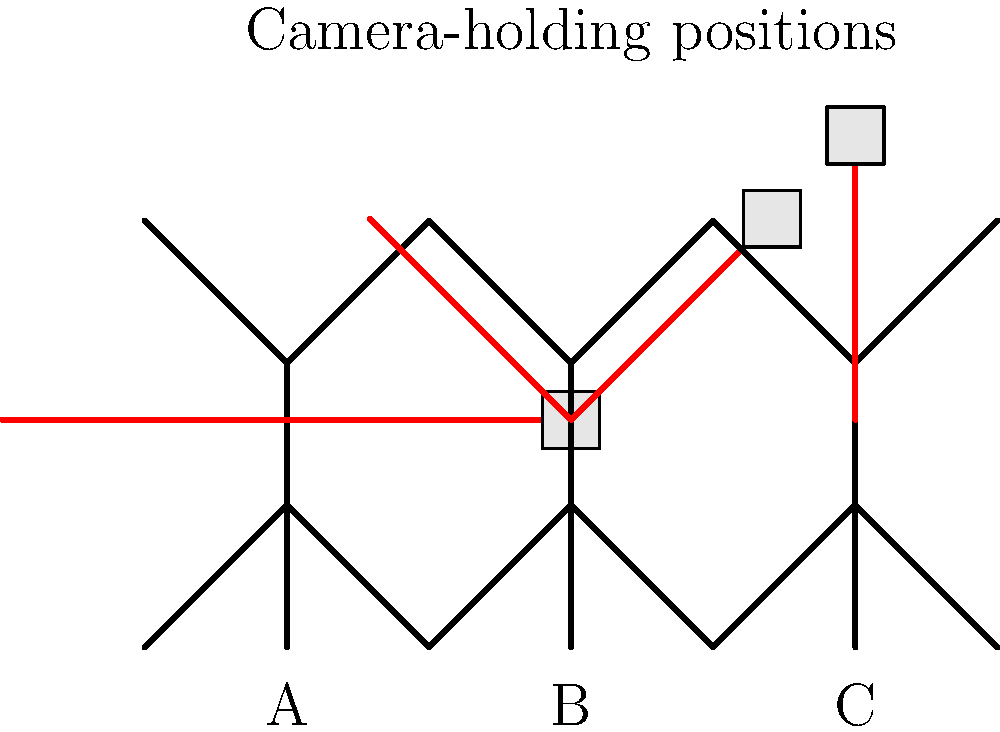Which of the camera-holding positions (A, B, or C) is likely to cause the least muscle strain during extended periods of black-and-white photography, considering the ergonomics of the posture? To determine which camera-holding position causes the least muscle strain during extended periods, we need to consider the ergonomics of each posture:

1. Position A (arms straight down):
   - Shoulders are in a neutral position
   - Elbows are fully extended
   - Wrists may be slightly bent
   - Minimal static load on shoulder muscles
   - May cause fatigue in forearms and hands over time

2. Position B (arms at 45-degree angle):
   - Shoulders are slightly raised and forward
   - Elbows are partially flexed
   - Wrists are in a more neutral position
   - Moderate static load on shoulder and upper arm muscles
   - Better distribution of muscle activity compared to A and C

3. Position C (arms raised to 90 degrees):
   - Shoulders are significantly raised and forward
   - Elbows are flexed at 90 degrees
   - Wrists may be in a neutral position
   - High static load on shoulder and upper arm muscles
   - Likely to cause the most fatigue and strain over time

Considering these factors:
- Position A may cause the least immediate strain but can lead to discomfort in the hands and wrists over time.
- Position C puts the most stress on the shoulders and upper arms, likely causing the most strain during extended use.
- Position B offers a compromise between the two extremes, allowing for better weight distribution and a more neutral wrist position.

For extended periods of photography, Position B (45-degree angle) is likely to cause the least overall muscle strain. It balances the load between different muscle groups and maintains a more natural posture, reducing the risk of fatigue and repetitive strain injuries.
Answer: B (45-degree angle) 